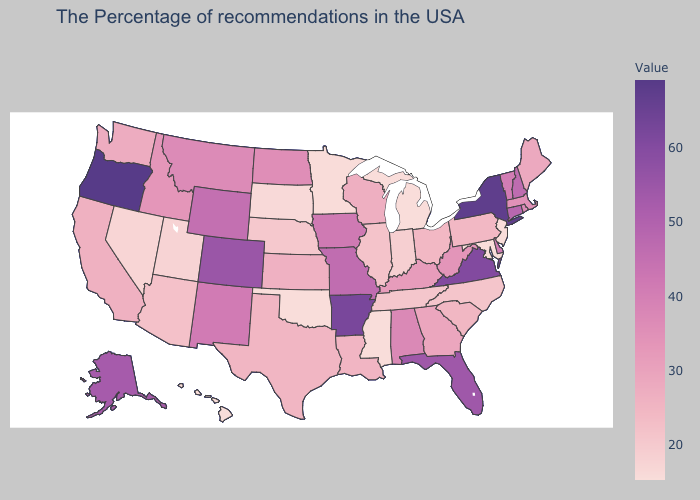Does Kansas have a higher value than Massachusetts?
Be succinct. No. Does California have a higher value than Nebraska?
Keep it brief. Yes. Does the map have missing data?
Write a very short answer. No. Does Arkansas have the highest value in the USA?
Give a very brief answer. No. Among the states that border Indiana , does Illinois have the lowest value?
Be succinct. No. Among the states that border Florida , which have the lowest value?
Quick response, please. Georgia. Among the states that border Illinois , does Indiana have the highest value?
Answer briefly. No. Does Mississippi have the lowest value in the USA?
Concise answer only. Yes. Does New Jersey have the lowest value in the Northeast?
Be succinct. Yes. 